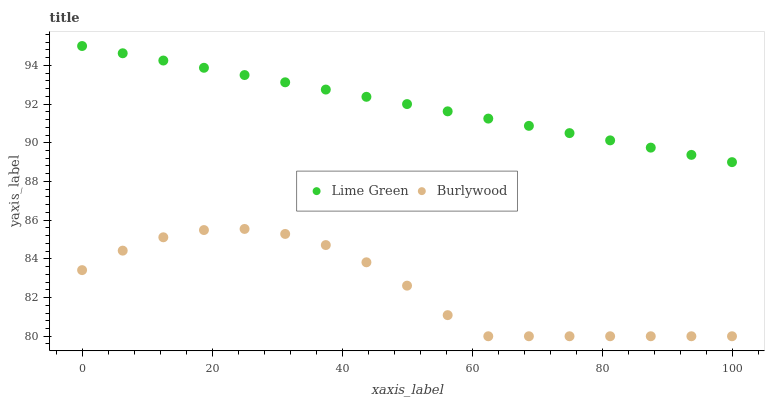Does Burlywood have the minimum area under the curve?
Answer yes or no. Yes. Does Lime Green have the maximum area under the curve?
Answer yes or no. Yes. Does Lime Green have the minimum area under the curve?
Answer yes or no. No. Is Lime Green the smoothest?
Answer yes or no. Yes. Is Burlywood the roughest?
Answer yes or no. Yes. Is Lime Green the roughest?
Answer yes or no. No. Does Burlywood have the lowest value?
Answer yes or no. Yes. Does Lime Green have the lowest value?
Answer yes or no. No. Does Lime Green have the highest value?
Answer yes or no. Yes. Is Burlywood less than Lime Green?
Answer yes or no. Yes. Is Lime Green greater than Burlywood?
Answer yes or no. Yes. Does Burlywood intersect Lime Green?
Answer yes or no. No. 